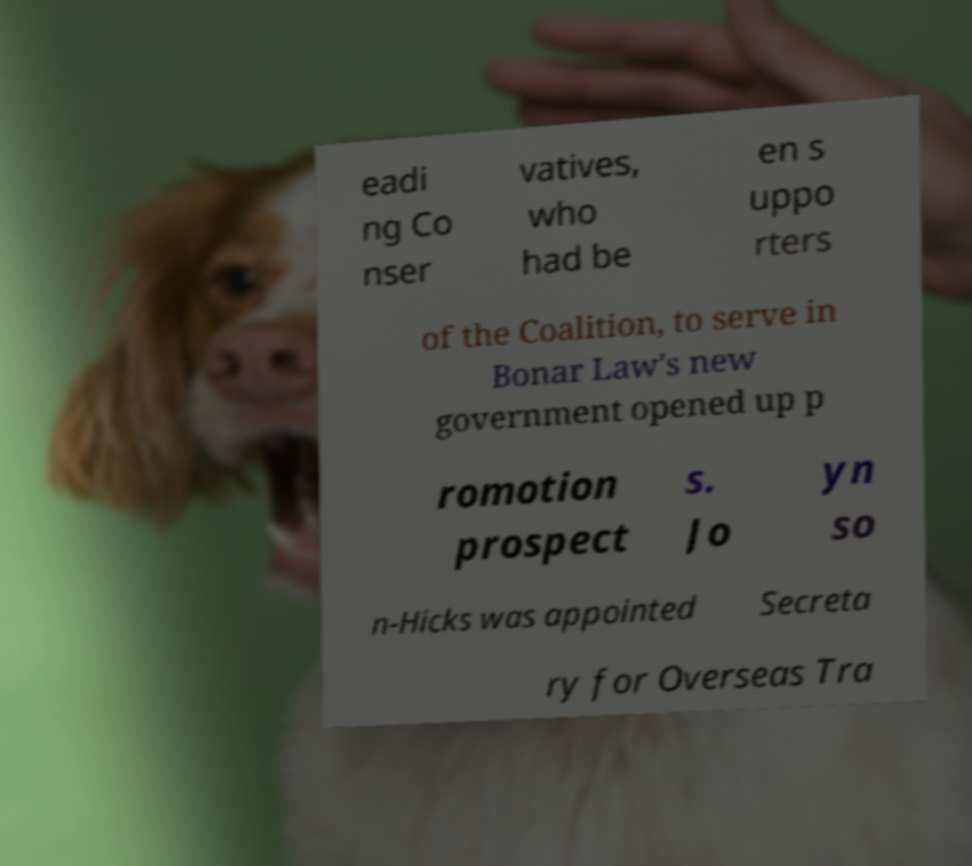There's text embedded in this image that I need extracted. Can you transcribe it verbatim? eadi ng Co nser vatives, who had be en s uppo rters of the Coalition, to serve in Bonar Law's new government opened up p romotion prospect s. Jo yn so n-Hicks was appointed Secreta ry for Overseas Tra 